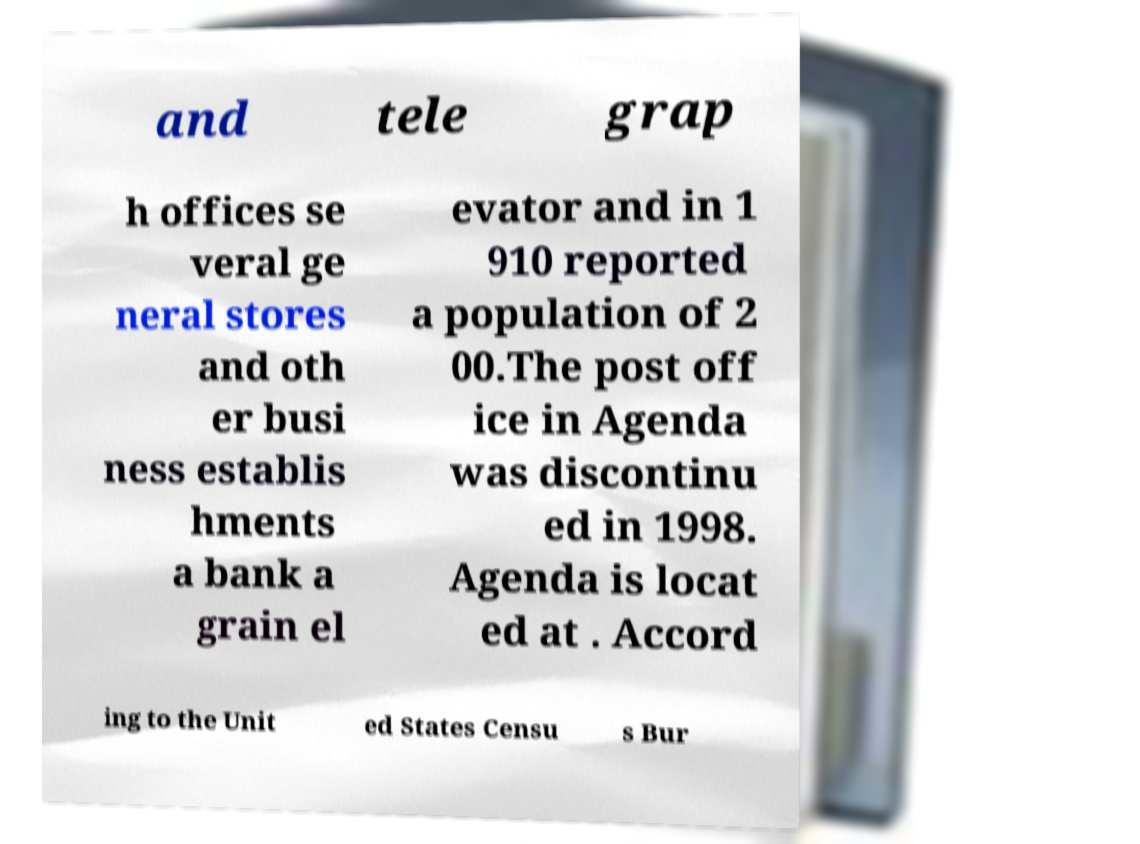I need the written content from this picture converted into text. Can you do that? and tele grap h offices se veral ge neral stores and oth er busi ness establis hments a bank a grain el evator and in 1 910 reported a population of 2 00.The post off ice in Agenda was discontinu ed in 1998. Agenda is locat ed at . Accord ing to the Unit ed States Censu s Bur 